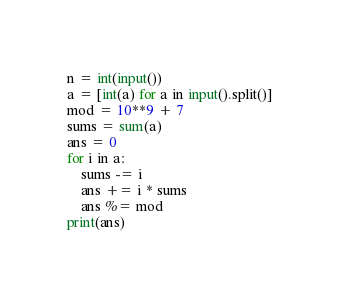Convert code to text. <code><loc_0><loc_0><loc_500><loc_500><_Python_>n = int(input())
a = [int(a) for a in input().split()]
mod = 10**9 + 7
sums = sum(a)
ans = 0
for i in a:
    sums -= i
    ans += i * sums
    ans %= mod
print(ans)</code> 